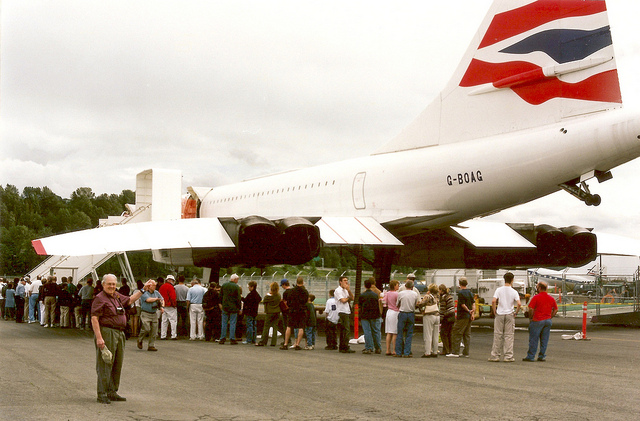Read and extract the text from this image. G-BOAG 